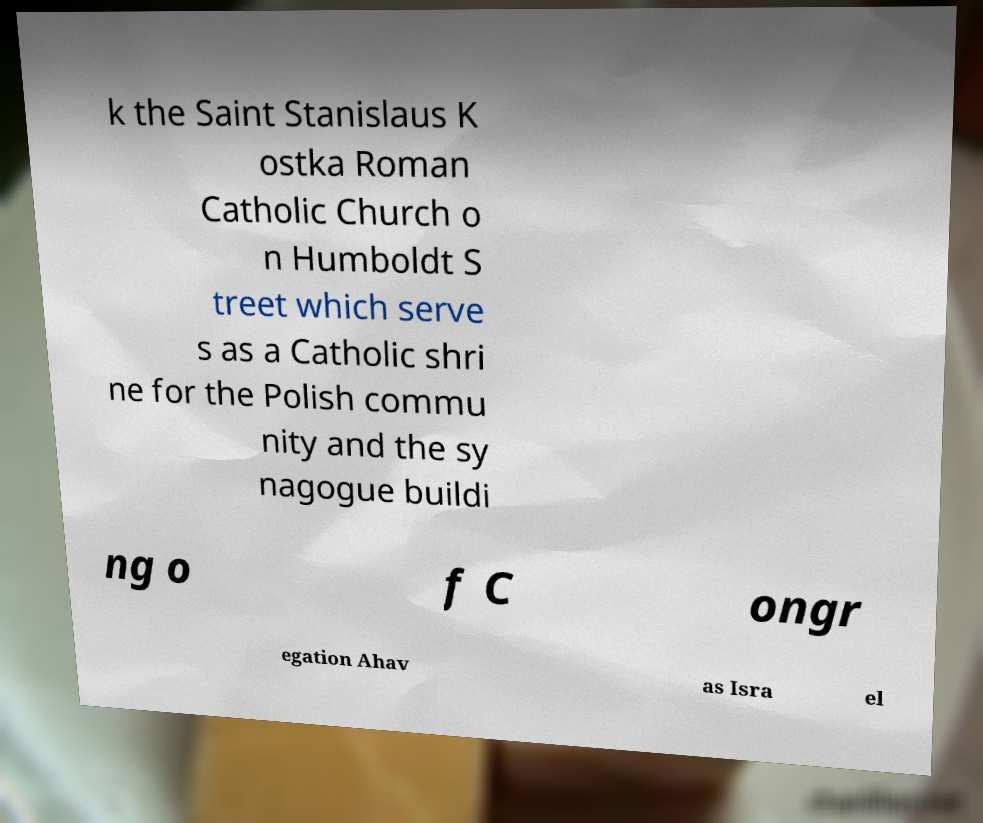Could you extract and type out the text from this image? k the Saint Stanislaus K ostka Roman Catholic Church o n Humboldt S treet which serve s as a Catholic shri ne for the Polish commu nity and the sy nagogue buildi ng o f C ongr egation Ahav as Isra el 